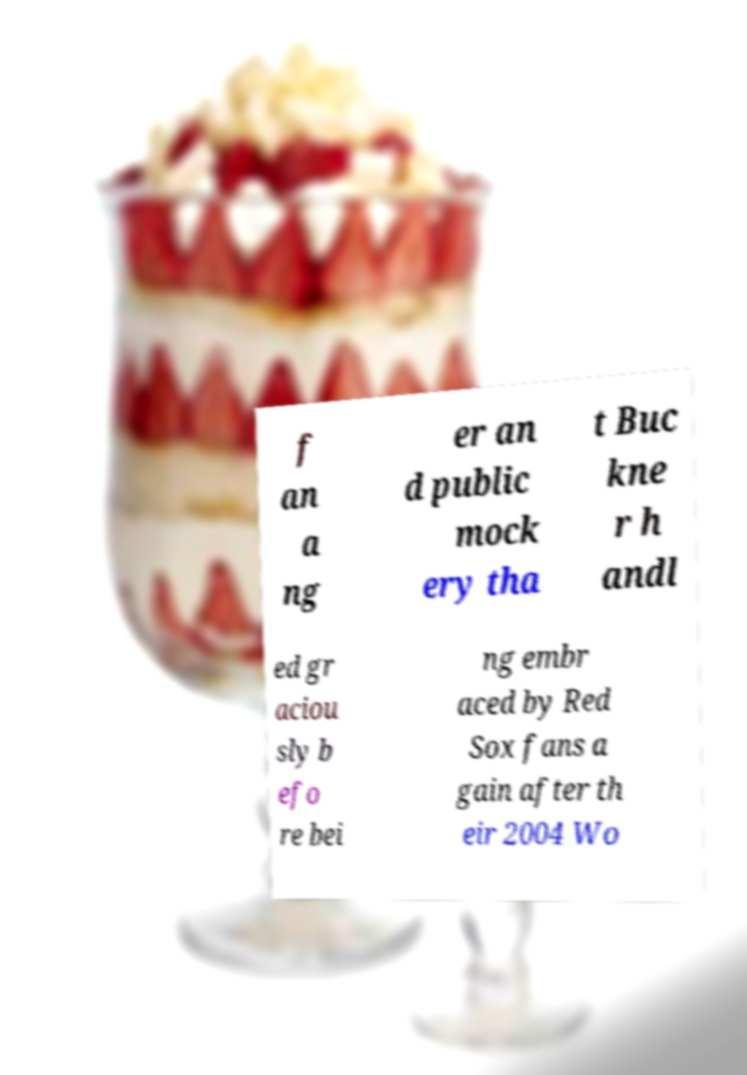What messages or text are displayed in this image? I need them in a readable, typed format. f an a ng er an d public mock ery tha t Buc kne r h andl ed gr aciou sly b efo re bei ng embr aced by Red Sox fans a gain after th eir 2004 Wo 